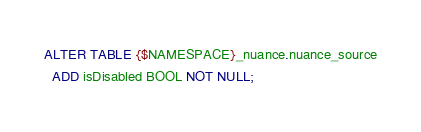Convert code to text. <code><loc_0><loc_0><loc_500><loc_500><_SQL_>ALTER TABLE {$NAMESPACE}_nuance.nuance_source
  ADD isDisabled BOOL NOT NULL;
</code> 